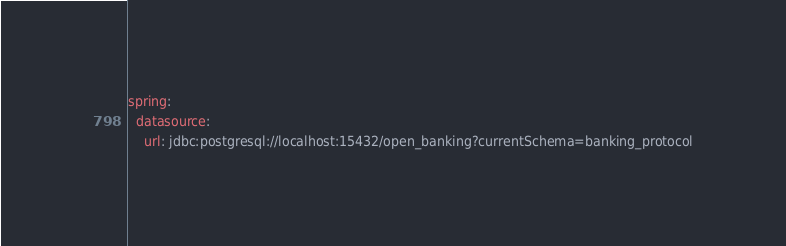Convert code to text. <code><loc_0><loc_0><loc_500><loc_500><_YAML_>spring:
  datasource:
    url: jdbc:postgresql://localhost:15432/open_banking?currentSchema=banking_protocol
</code> 